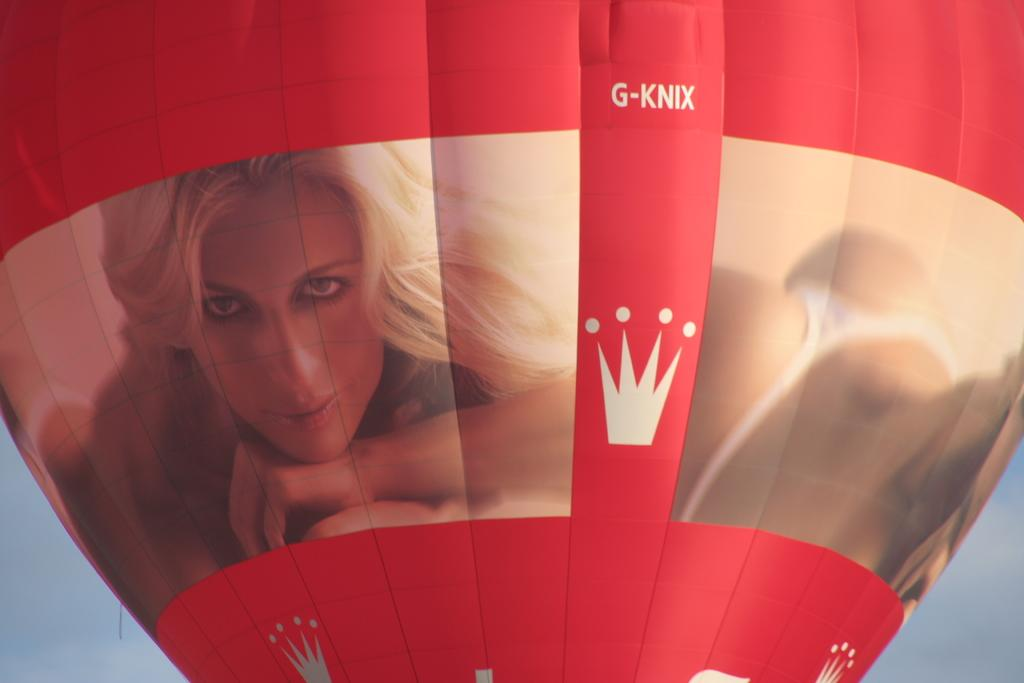What is the main object in the picture? There is a parachute in the picture. Is there any design or image on the parachute? Yes, the parachute has a photo of a girl smiling on it. What can be seen in the background of the picture? The sky is visible in the background of the picture. What type of pickle is hanging from the parachute in the image? There is no pickle present in the image; the parachute has a photo of a girl smiling on it. What color is the silver door in the image? There is no silver door present in the image; the background is the sky. 